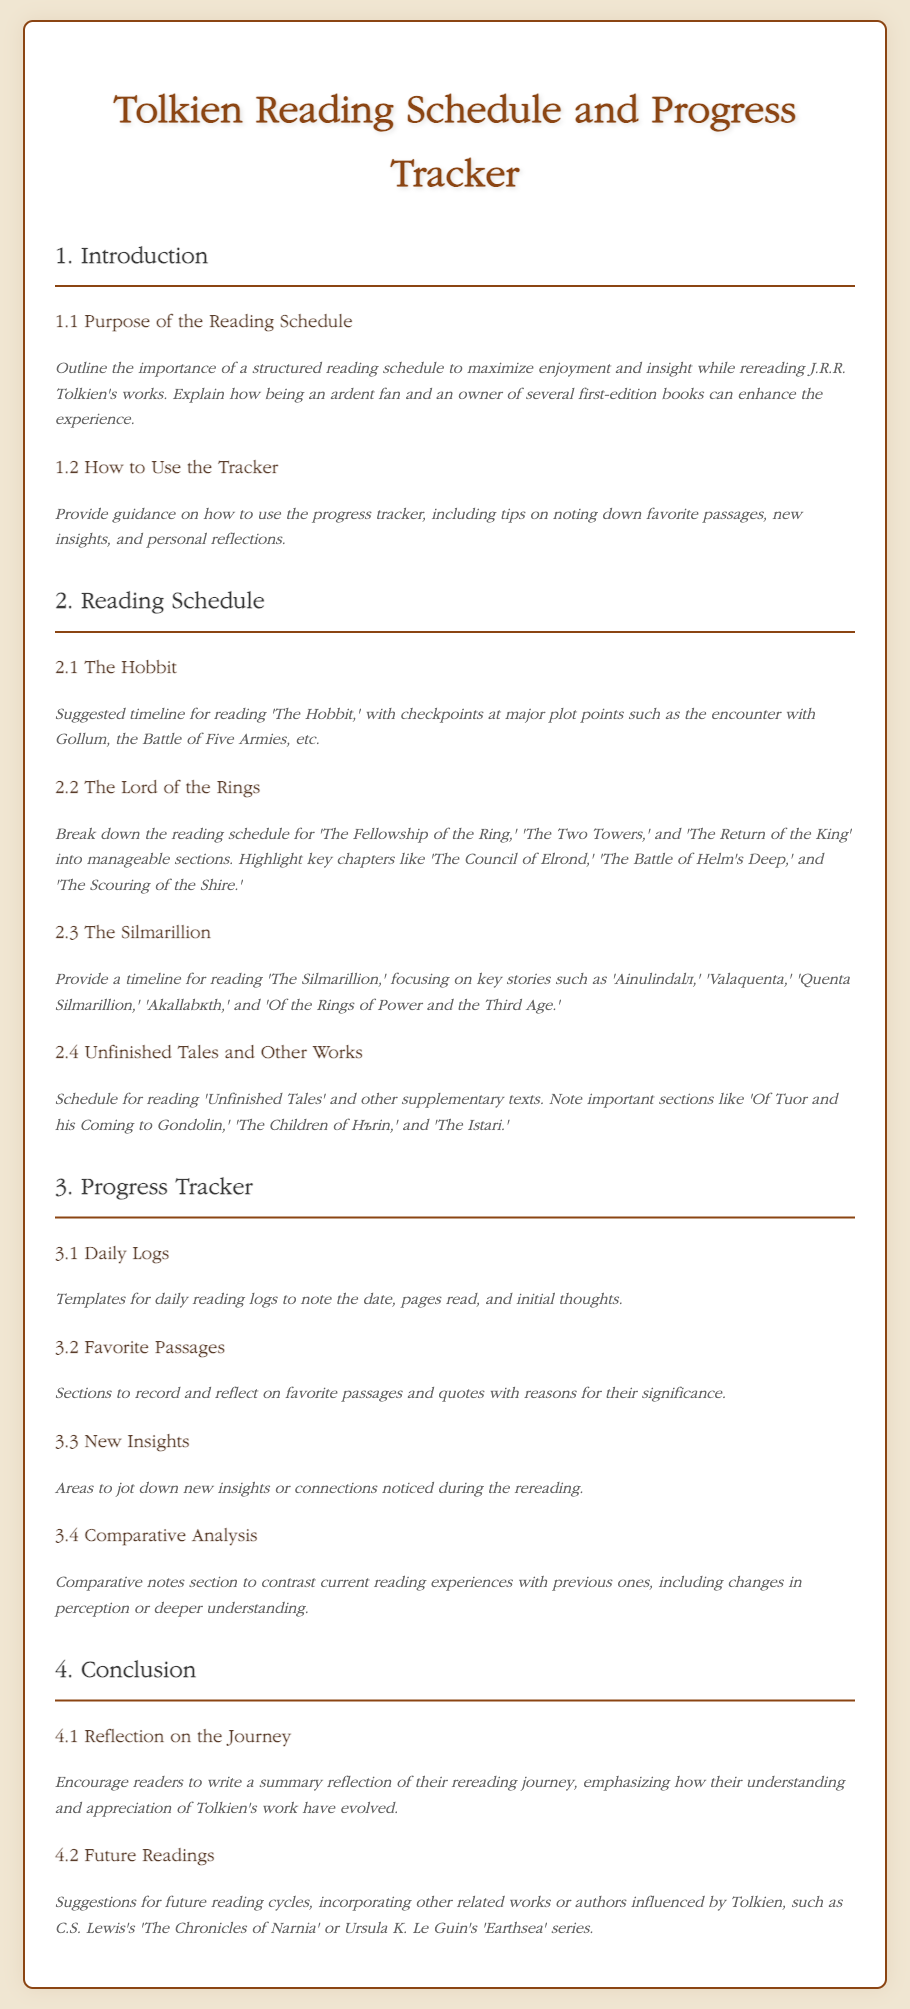What is the title of the document? The title of the document is mentioned at the top of the content section.
Answer: Tolkien Reading Schedule and Progress Tracker What is the first section of the document? The first section is outlined in the table of contents, specifically as the introduction.
Answer: Introduction How many key readings are suggested in section 2? The document details specific key readings under section 2, which are The Hobbit, The Lord of the Rings, The Silmarillion, and Unfinished Tales and Other Works.
Answer: 4 What does section 3.2 focus on? Section 3.2 describes what to record regarding personal favorites during the reading.
Answer: Favorite Passages What is one key chapter highlighted in The Lord of the Rings reading schedule? The document lists notable chapters within the reading schedule for The Lord of the Rings.
Answer: The Council of Elrond What is the purpose of the progress tracker section? The purpose of the progress tracker is outlined to assist in noting down reading details and reflections.
Answer: To note reading details and reflections Which work is suggested for future readings alongside Tolkien's? The document mentions other authors whose works are influenced by Tolkien under future readings.
Answer: The Chronicles of Narnia What is a suggested activity in section 4.1? Section 4.1 encourages readers to complete a specific reflective activity after rereading.
Answer: Write a summary reflection 